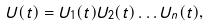<formula> <loc_0><loc_0><loc_500><loc_500>U ( t ) = U _ { 1 } ( t ) U _ { 2 } ( t ) \dots U _ { n } ( t ) ,</formula> 